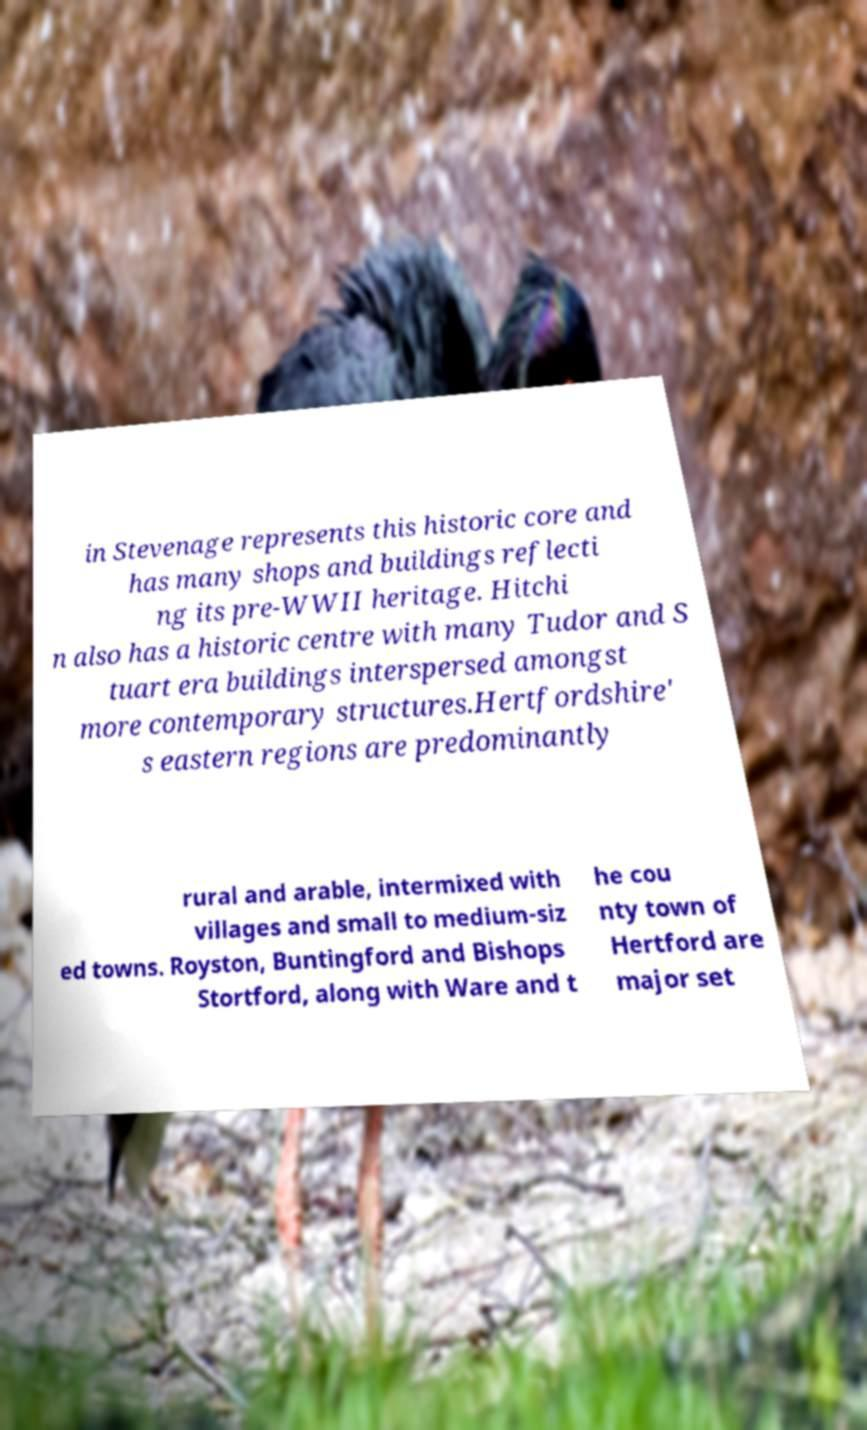Could you extract and type out the text from this image? in Stevenage represents this historic core and has many shops and buildings reflecti ng its pre-WWII heritage. Hitchi n also has a historic centre with many Tudor and S tuart era buildings interspersed amongst more contemporary structures.Hertfordshire' s eastern regions are predominantly rural and arable, intermixed with villages and small to medium-siz ed towns. Royston, Buntingford and Bishops Stortford, along with Ware and t he cou nty town of Hertford are major set 